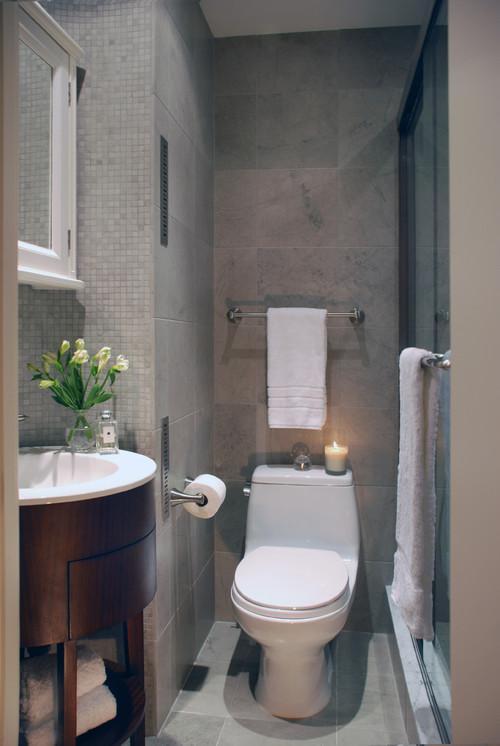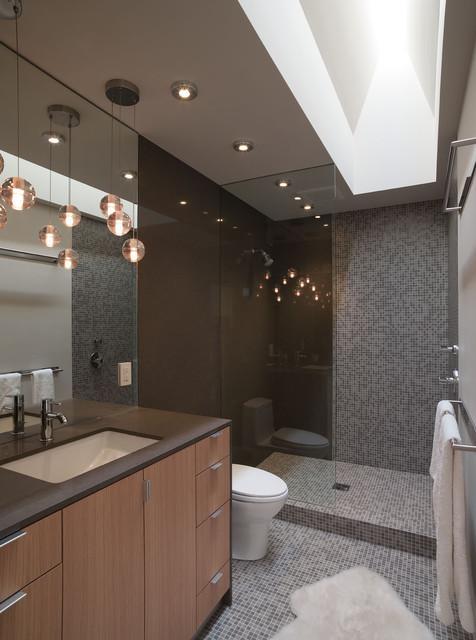The first image is the image on the left, the second image is the image on the right. For the images displayed, is the sentence "A commode is positioned in front of one side of a bathroom vanity, with a sink installed beside it in a wider area over a storage space." factually correct? Answer yes or no. No. The first image is the image on the left, the second image is the image on the right. Given the left and right images, does the statement "A cabinet sits behind a toilet in the image on the right." hold true? Answer yes or no. No. 